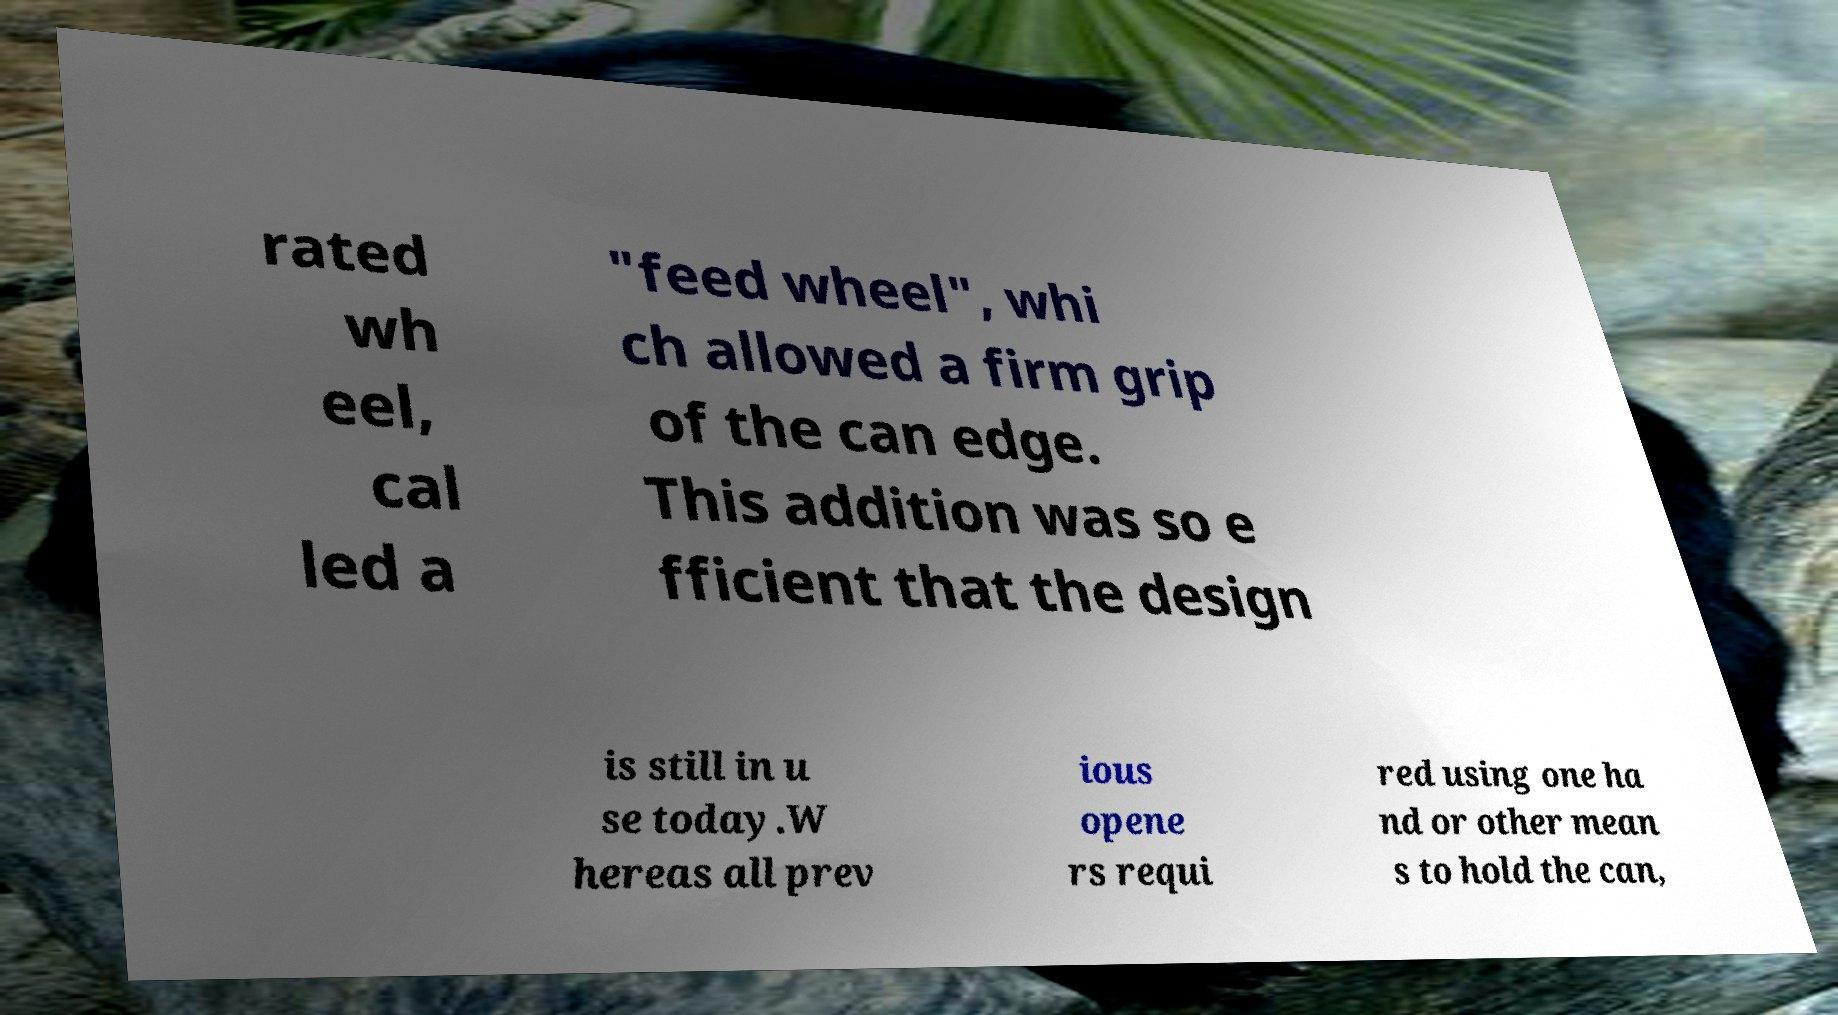Can you accurately transcribe the text from the provided image for me? rated wh eel, cal led a "feed wheel", whi ch allowed a firm grip of the can edge. This addition was so e fficient that the design is still in u se today.W hereas all prev ious opene rs requi red using one ha nd or other mean s to hold the can, 